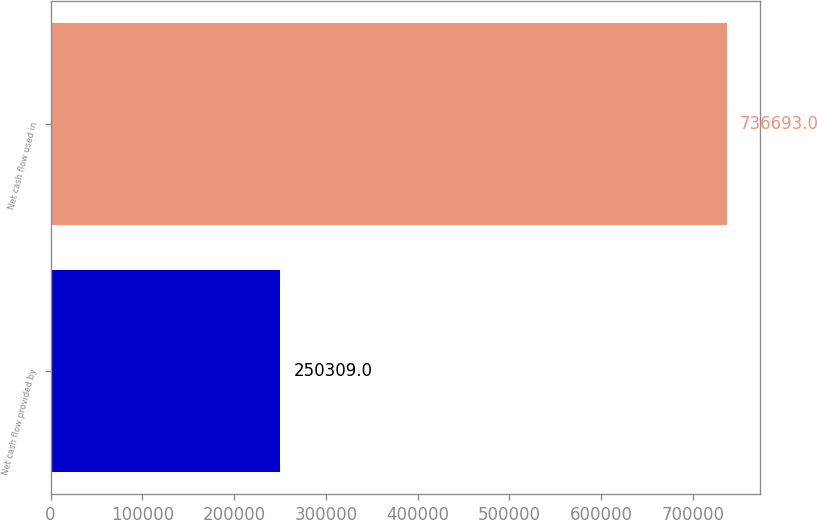Convert chart. <chart><loc_0><loc_0><loc_500><loc_500><bar_chart><fcel>Net cash flow provided by<fcel>Net cash flow used in<nl><fcel>250309<fcel>736693<nl></chart> 